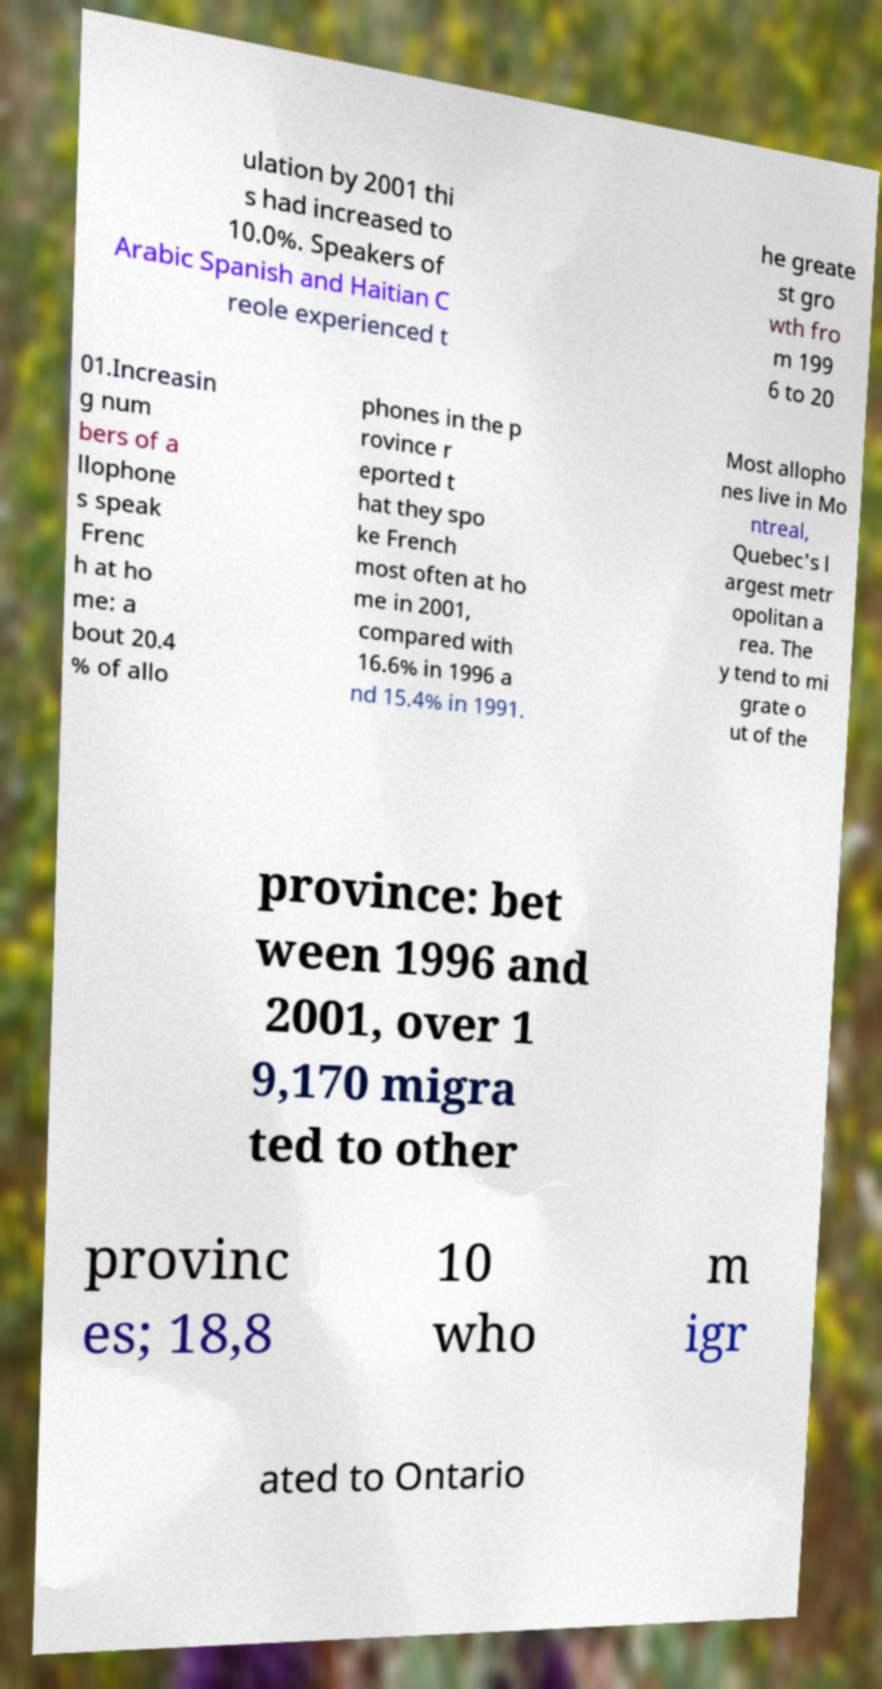For documentation purposes, I need the text within this image transcribed. Could you provide that? ulation by 2001 thi s had increased to 10.0%. Speakers of Arabic Spanish and Haitian C reole experienced t he greate st gro wth fro m 199 6 to 20 01.Increasin g num bers of a llophone s speak Frenc h at ho me: a bout 20.4 % of allo phones in the p rovince r eported t hat they spo ke French most often at ho me in 2001, compared with 16.6% in 1996 a nd 15.4% in 1991. Most allopho nes live in Mo ntreal, Quebec's l argest metr opolitan a rea. The y tend to mi grate o ut of the province: bet ween 1996 and 2001, over 1 9,170 migra ted to other provinc es; 18,8 10 who m igr ated to Ontario 